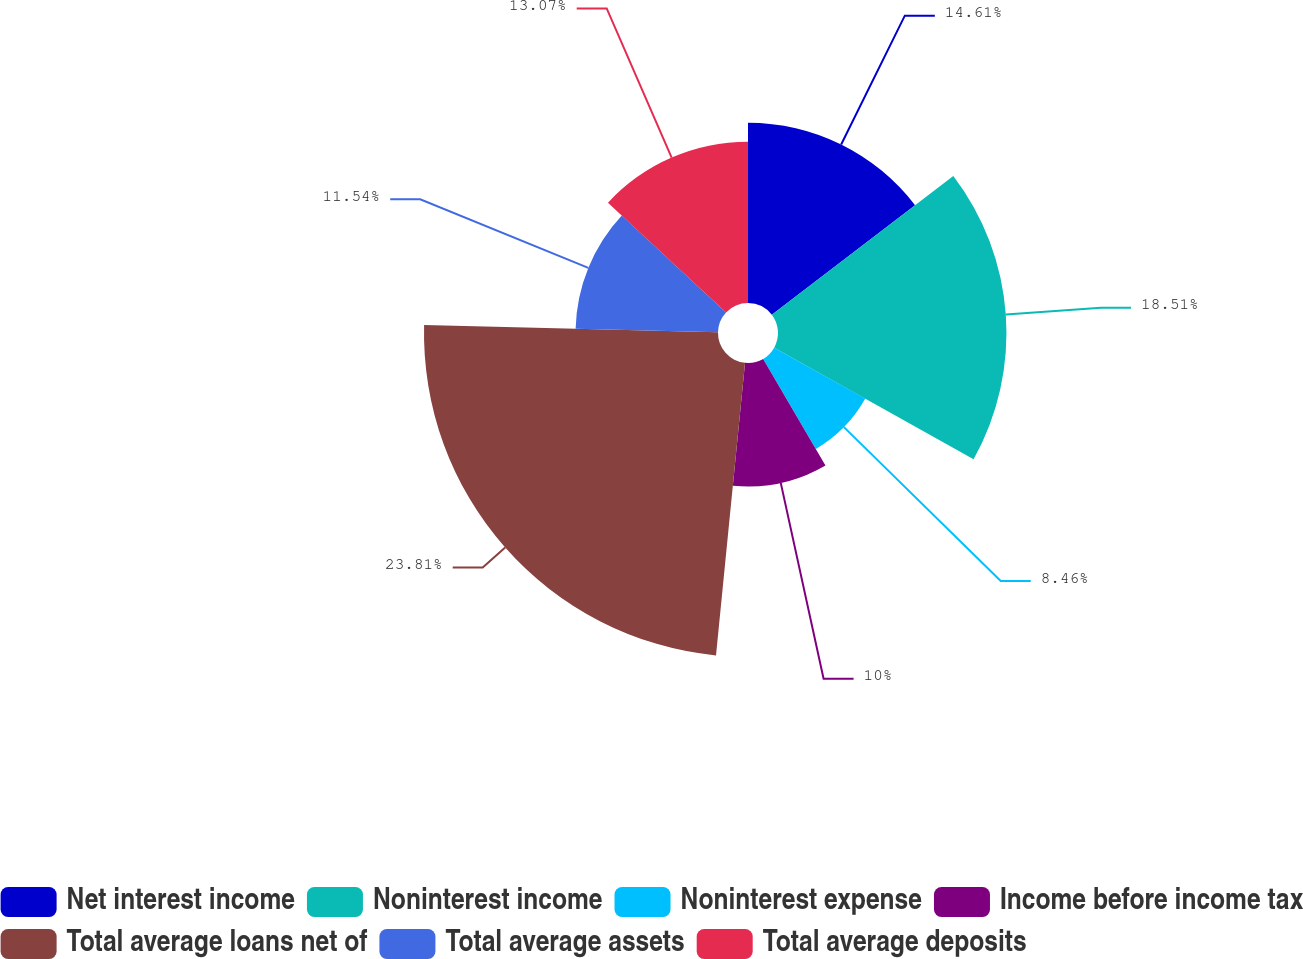Convert chart. <chart><loc_0><loc_0><loc_500><loc_500><pie_chart><fcel>Net interest income<fcel>Noninterest income<fcel>Noninterest expense<fcel>Income before income tax<fcel>Total average loans net of<fcel>Total average assets<fcel>Total average deposits<nl><fcel>14.61%<fcel>18.51%<fcel>8.46%<fcel>10.0%<fcel>23.82%<fcel>11.54%<fcel>13.07%<nl></chart> 